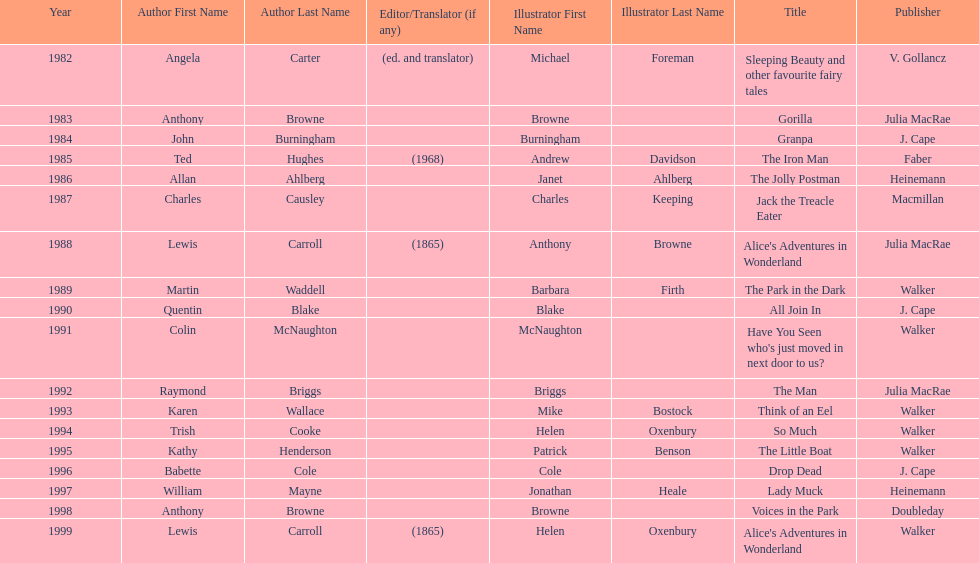Could you parse the entire table? {'header': ['Year', 'Author First Name', 'Author Last Name', 'Editor/Translator (if any)', 'Illustrator First Name', 'Illustrator Last Name', 'Title', 'Publisher'], 'rows': [['1982', 'Angela', 'Carter', '(ed. and translator)', 'Michael', 'Foreman', 'Sleeping Beauty and other favourite fairy tales', 'V. Gollancz'], ['1983', 'Anthony', 'Browne', '', 'Browne', '', 'Gorilla', 'Julia MacRae'], ['1984', 'John', 'Burningham', '', 'Burningham', '', 'Granpa', 'J. Cape'], ['1985', 'Ted', 'Hughes', '(1968)', 'Andrew', 'Davidson', 'The Iron Man', 'Faber'], ['1986', 'Allan', 'Ahlberg', '', 'Janet', 'Ahlberg', 'The Jolly Postman', 'Heinemann'], ['1987', 'Charles', 'Causley', '', 'Charles', 'Keeping', 'Jack the Treacle Eater', 'Macmillan'], ['1988', 'Lewis', 'Carroll', '(1865)', 'Anthony', 'Browne', "Alice's Adventures in Wonderland", 'Julia MacRae'], ['1989', 'Martin', 'Waddell', '', 'Barbara', 'Firth', 'The Park in the Dark', 'Walker'], ['1990', 'Quentin', 'Blake', '', 'Blake', '', 'All Join In', 'J. Cape'], ['1991', 'Colin', 'McNaughton', '', 'McNaughton', '', "Have You Seen who's just moved in next door to us?", 'Walker'], ['1992', 'Raymond', 'Briggs', '', 'Briggs', '', 'The Man', 'Julia MacRae'], ['1993', 'Karen', 'Wallace', '', 'Mike', 'Bostock', 'Think of an Eel', 'Walker'], ['1994', 'Trish', 'Cooke', '', 'Helen', 'Oxenbury', 'So Much', 'Walker'], ['1995', 'Kathy', 'Henderson', '', 'Patrick', 'Benson', 'The Little Boat', 'Walker'], ['1996', 'Babette', 'Cole', '', 'Cole', '', 'Drop Dead', 'J. Cape'], ['1997', 'William', 'Mayne', '', 'Jonathan', 'Heale', 'Lady Muck', 'Heinemann'], ['1998', 'Anthony', 'Browne', '', 'Browne', '', 'Voices in the Park', 'Doubleday'], ['1999', 'Lewis', 'Carroll', '(1865)', 'Helen', 'Oxenbury', "Alice's Adventures in Wonderland", 'Walker']]} How many total titles were published by walker? 5. 